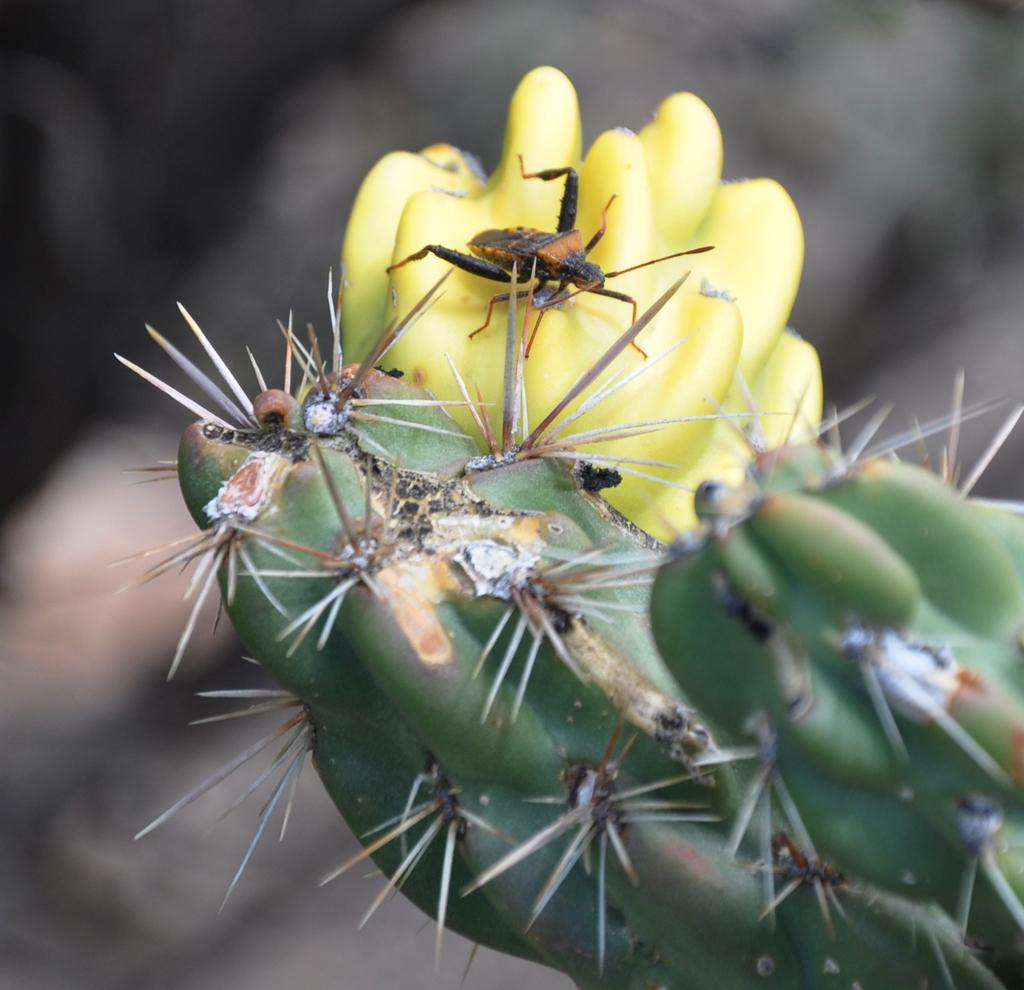What type of living organism can be seen in the image? There is a plant in the image. What specific part of the plant is visible? There is a flower on the plant. Are there any other living organisms interacting with the plant? Yes, there is an insect on the flower. How would you describe the background of the image? The background of the image is blurry. What type of mark can be seen on the fork in the image? There is no fork present in the image; it features a plant with a flower and an insect. 